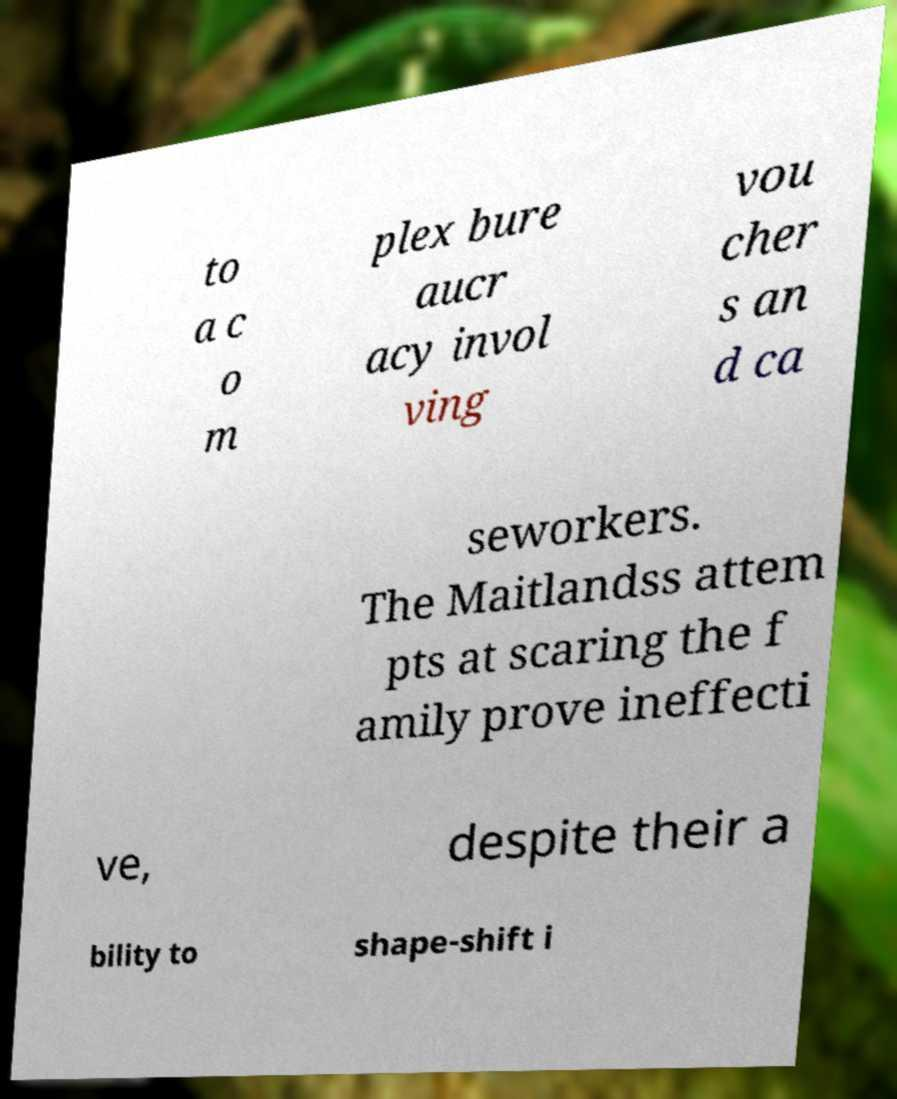There's text embedded in this image that I need extracted. Can you transcribe it verbatim? to a c o m plex bure aucr acy invol ving vou cher s an d ca seworkers. The Maitlandss attem pts at scaring the f amily prove ineffecti ve, despite their a bility to shape-shift i 